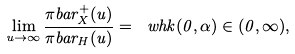Convert formula to latex. <formula><loc_0><loc_0><loc_500><loc_500>\lim _ { u \to \infty } \frac { \pi b a r _ { X } ^ { + } ( u ) } { \pi b a r _ { H } ( u ) } = \ w h k ( 0 , \alpha ) \in ( 0 , \infty ) ,</formula> 